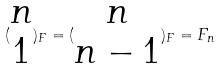Convert formula to latex. <formula><loc_0><loc_0><loc_500><loc_500>( \begin{matrix} n \\ 1 \end{matrix} ) _ { F } = ( \begin{matrix} n \\ n - 1 \end{matrix} ) _ { F } = F _ { n }</formula> 